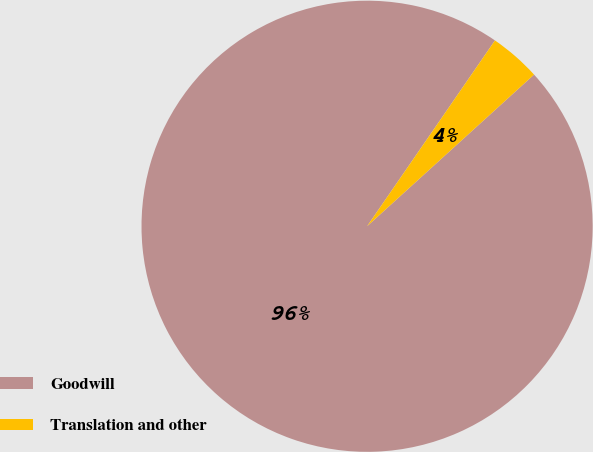Convert chart to OTSL. <chart><loc_0><loc_0><loc_500><loc_500><pie_chart><fcel>Goodwill<fcel>Translation and other<nl><fcel>96.33%<fcel>3.67%<nl></chart> 